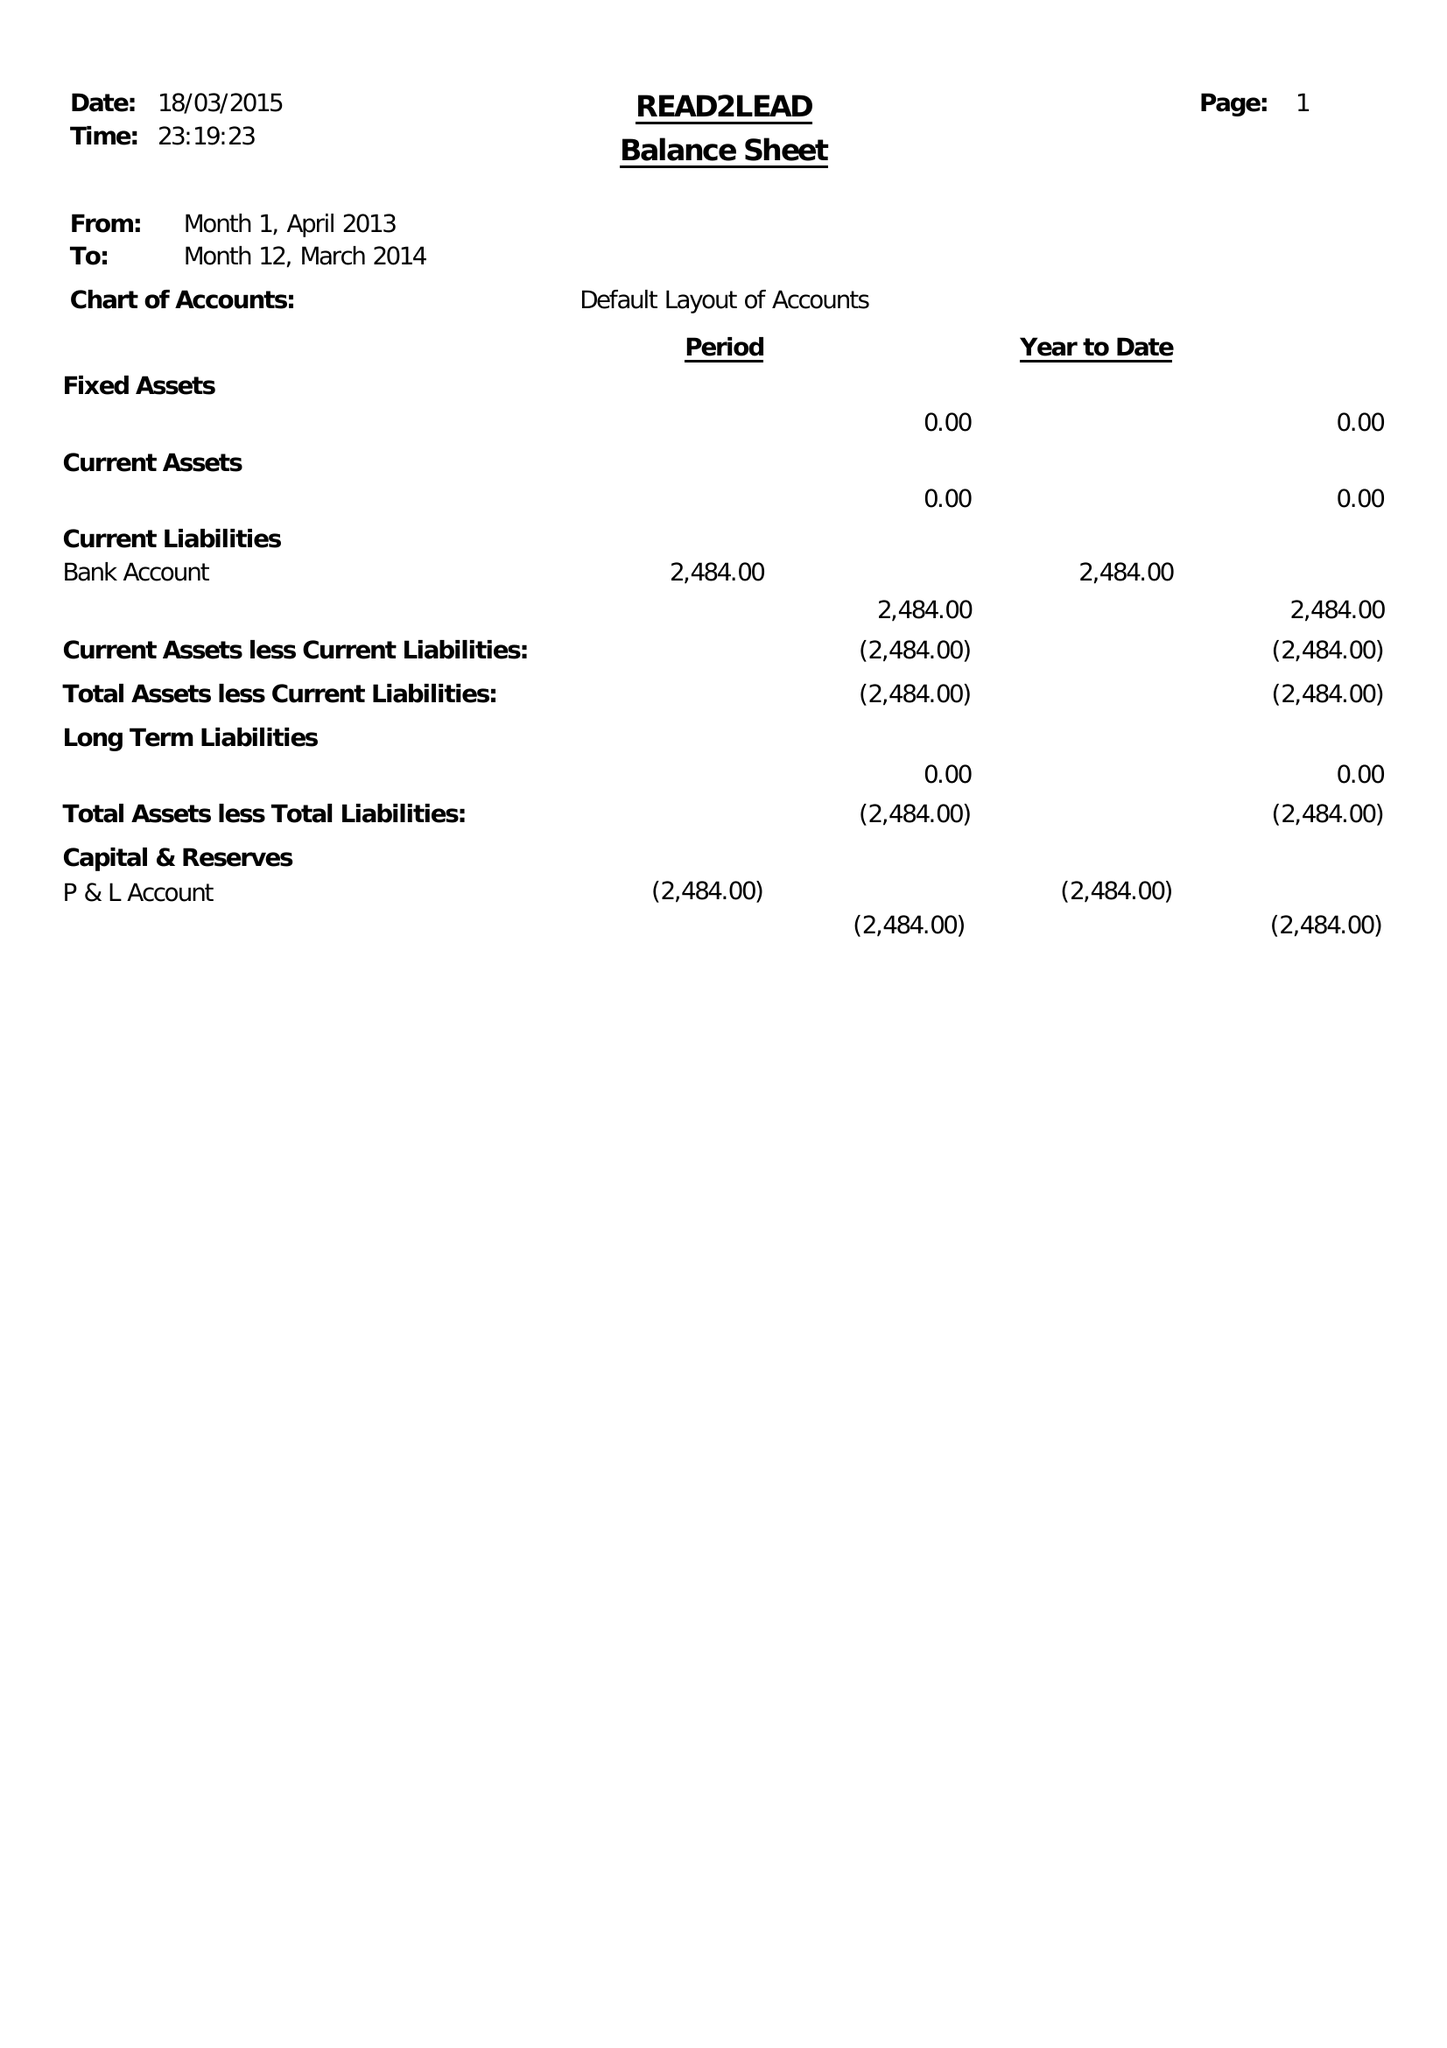What is the value for the spending_annually_in_british_pounds?
Answer the question using a single word or phrase. 18234.00 